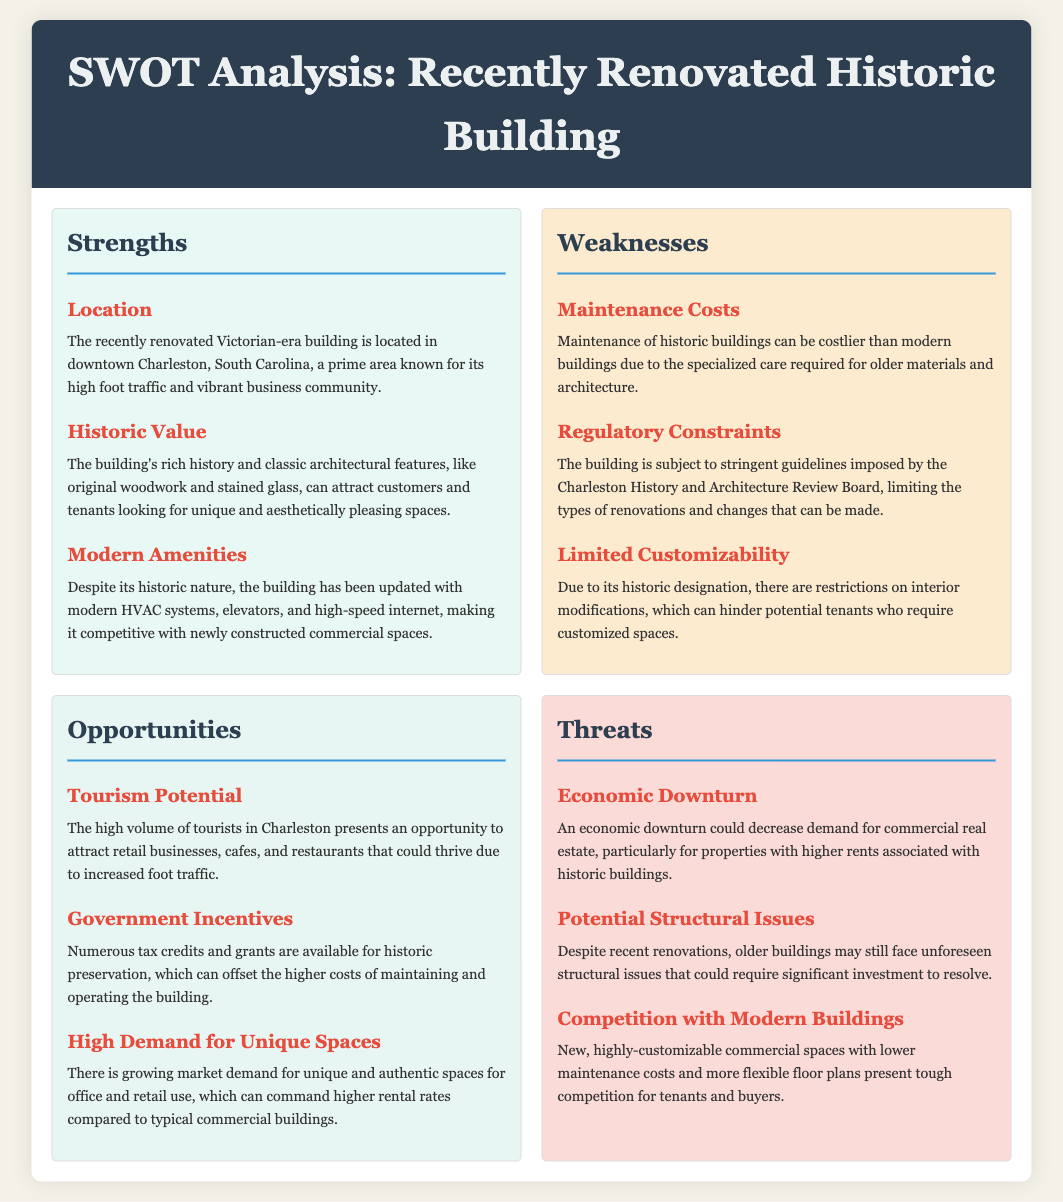What is the building's historic era? The building is identified as Victorian-era in the document.
Answer: Victorian-era Where is the building located? The document specifies the location as downtown Charleston, South Carolina.
Answer: downtown Charleston, South Carolina What is one of the strengths mentioned about the building? The document lists "Modern Amenities" as one of the strengths of the property.
Answer: Modern Amenities What maintenance issue is mentioned as a weakness? The document notes that "Maintenance Costs" can be higher due to specialized care for older buildings.
Answer: Maintenance Costs What is one opportunity identified linked to tourism? The document suggests that "Tourism Potential" provides an opportunity for retail businesses, cafes, and restaurants.
Answer: Tourism Potential What could decrease demand for this building according to the threats? The document warns that an "Economic Downturn" could decrease demand for commercial real estate.
Answer: Economic Downturn What is a unique aspect that could increase rental rates? The document highlights "High Demand for Unique Spaces" as a factor that can command higher rental rates.
Answer: High Demand for Unique Spaces What regulatory constraints are mentioned regarding renovations? The document explains that the building is subject to "Regulatory Constraints" from the Charleston History and Architecture Review Board.
Answer: Regulatory Constraints What was recently invested in the building's upgrades? The document states that the building has been updated with "modern HVAC systems, elevators, and high-speed internet."
Answer: modern HVAC systems, elevators, and high-speed internet 